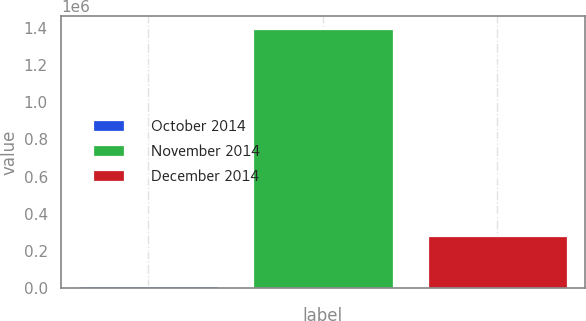Convert chart. <chart><loc_0><loc_0><loc_500><loc_500><bar_chart><fcel>October 2014<fcel>November 2014<fcel>December 2014<nl><fcel>7862<fcel>1.39573e+06<fcel>279982<nl></chart> 